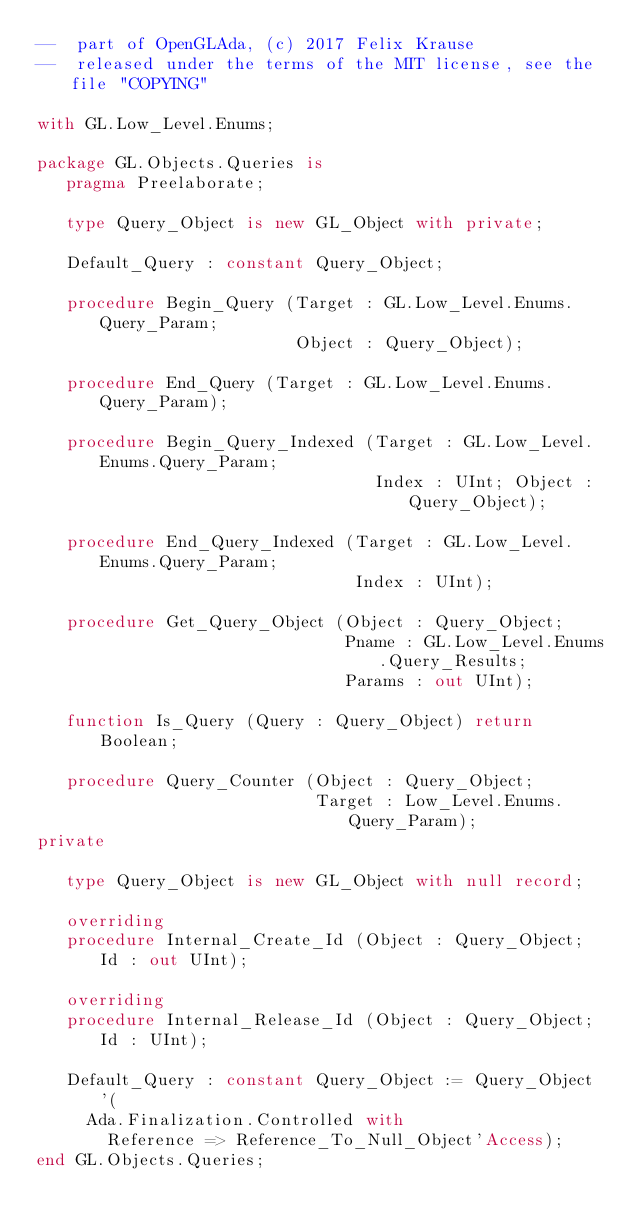Convert code to text. <code><loc_0><loc_0><loc_500><loc_500><_Ada_>--  part of OpenGLAda, (c) 2017 Felix Krause
--  released under the terms of the MIT license, see the file "COPYING"

with GL.Low_Level.Enums;

package GL.Objects.Queries is
   pragma Preelaborate;

   type Query_Object is new GL_Object with private;

   Default_Query : constant Query_Object;

   procedure Begin_Query (Target : GL.Low_Level.Enums.Query_Param;
                          Object : Query_Object);

   procedure End_Query (Target : GL.Low_Level.Enums.Query_Param);

   procedure Begin_Query_Indexed (Target : GL.Low_Level.Enums.Query_Param;
                                  Index : UInt; Object : Query_Object);

   procedure End_Query_Indexed (Target : GL.Low_Level.Enums.Query_Param;
                                Index : UInt);

   procedure Get_Query_Object (Object : Query_Object;
                               Pname : GL.Low_Level.Enums.Query_Results;
                               Params : out UInt);

   function Is_Query (Query : Query_Object) return Boolean;

   procedure Query_Counter (Object : Query_Object;
                            Target : Low_Level.Enums.Query_Param);
private

   type Query_Object is new GL_Object with null record;

   overriding
   procedure Internal_Create_Id (Object : Query_Object; Id : out UInt);

   overriding
   procedure Internal_Release_Id (Object : Query_Object; Id : UInt);

   Default_Query : constant Query_Object := Query_Object'(
     Ada.Finalization.Controlled with
       Reference => Reference_To_Null_Object'Access);
end GL.Objects.Queries;
</code> 